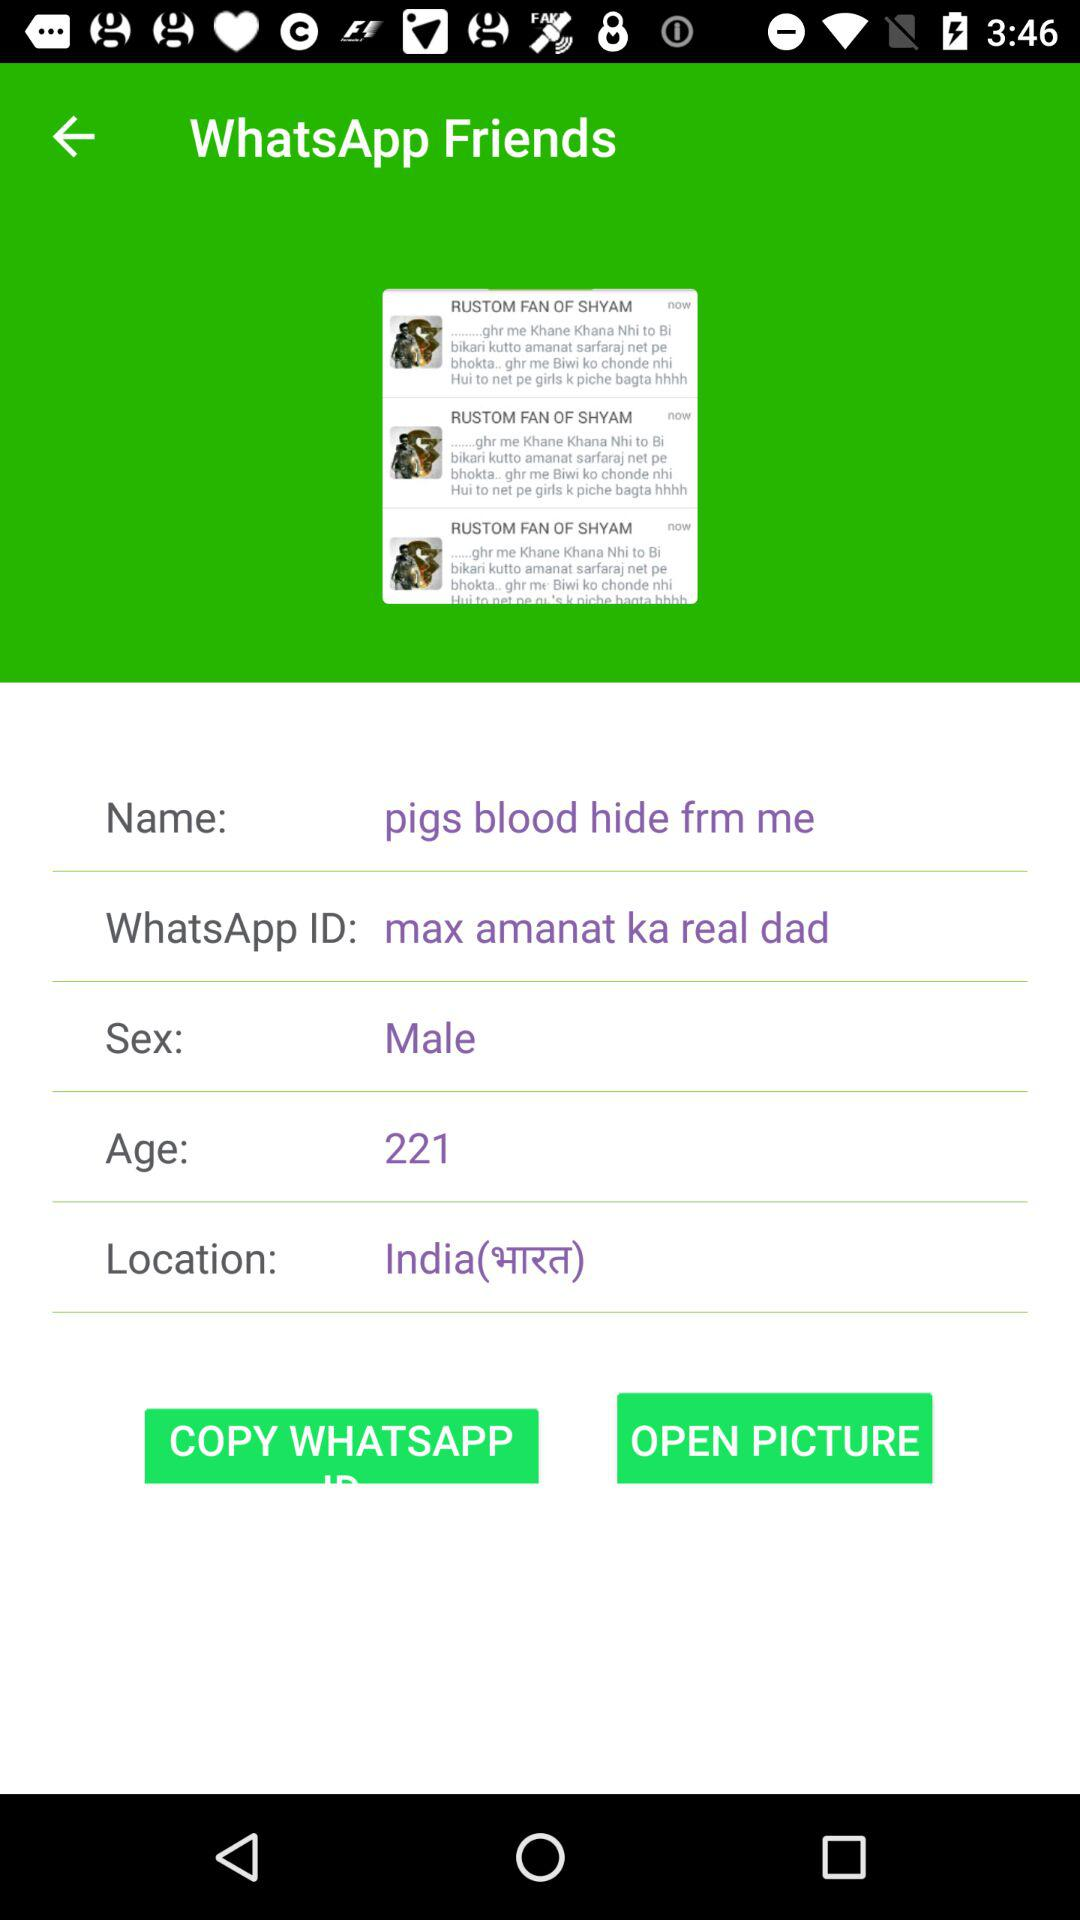What is the given name? The given name is "pigs blood hide frm me". 